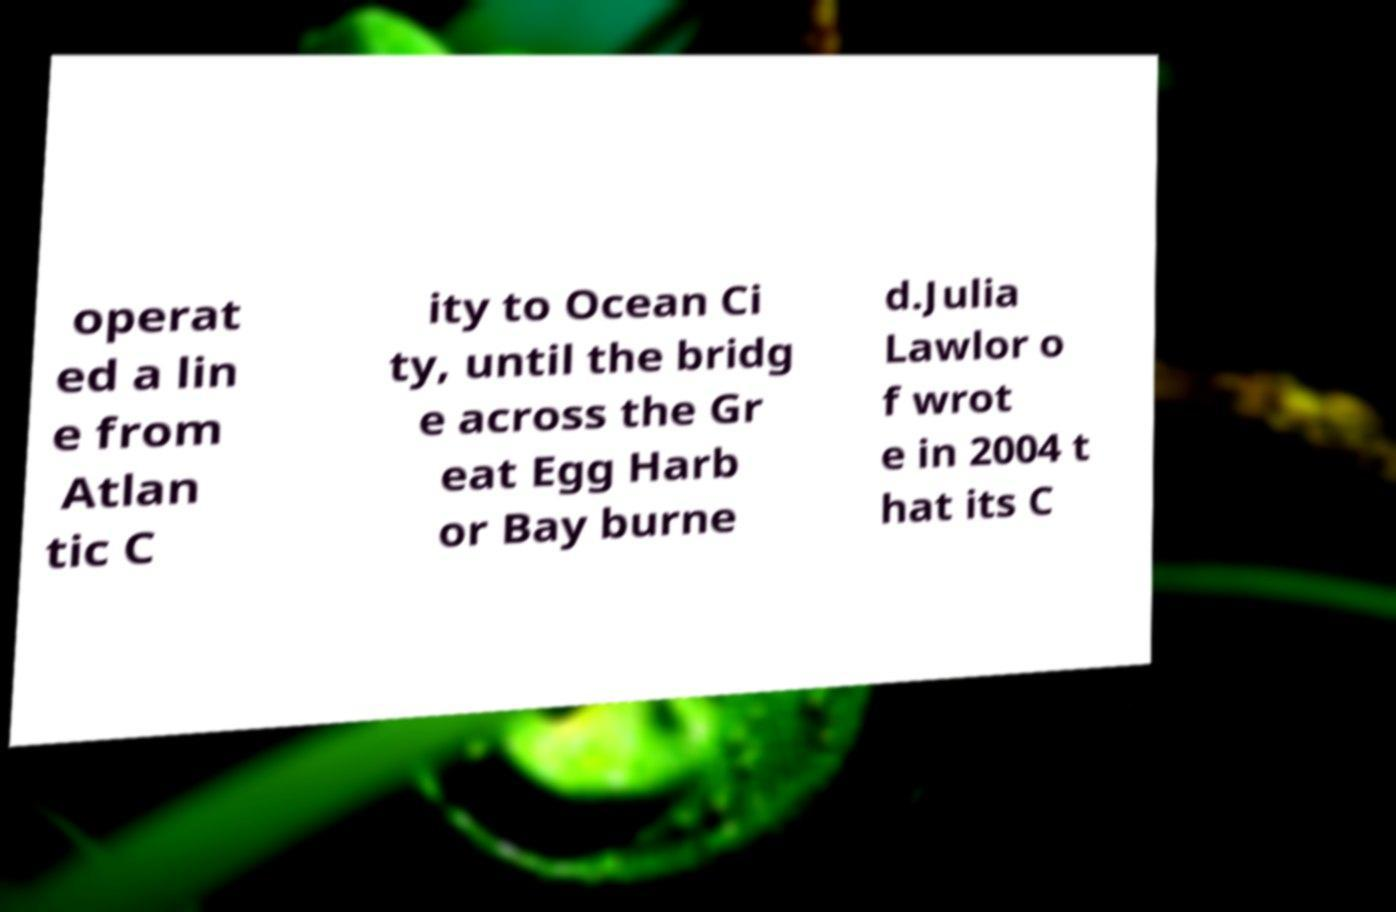For documentation purposes, I need the text within this image transcribed. Could you provide that? operat ed a lin e from Atlan tic C ity to Ocean Ci ty, until the bridg e across the Gr eat Egg Harb or Bay burne d.Julia Lawlor o f wrot e in 2004 t hat its C 